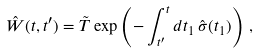Convert formula to latex. <formula><loc_0><loc_0><loc_500><loc_500>\hat { W } ( t , t ^ { \prime } ) = \tilde { T } \exp \left ( - \int _ { t ^ { \prime } } ^ { t } d t _ { 1 } \, \hat { \sigma } ( t _ { 1 } ) \right ) \, ,</formula> 